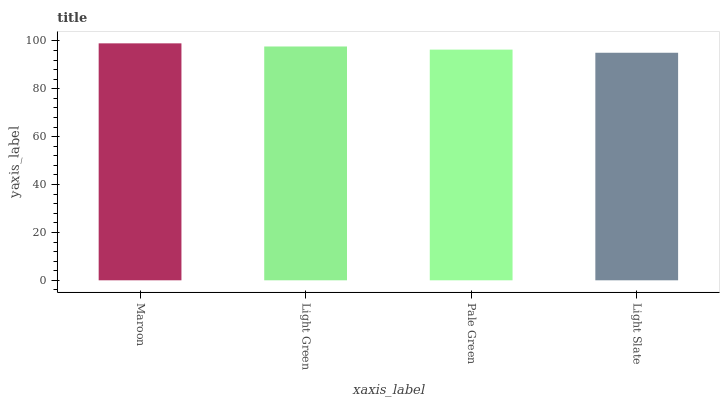Is Light Slate the minimum?
Answer yes or no. Yes. Is Maroon the maximum?
Answer yes or no. Yes. Is Light Green the minimum?
Answer yes or no. No. Is Light Green the maximum?
Answer yes or no. No. Is Maroon greater than Light Green?
Answer yes or no. Yes. Is Light Green less than Maroon?
Answer yes or no. Yes. Is Light Green greater than Maroon?
Answer yes or no. No. Is Maroon less than Light Green?
Answer yes or no. No. Is Light Green the high median?
Answer yes or no. Yes. Is Pale Green the low median?
Answer yes or no. Yes. Is Light Slate the high median?
Answer yes or no. No. Is Light Slate the low median?
Answer yes or no. No. 